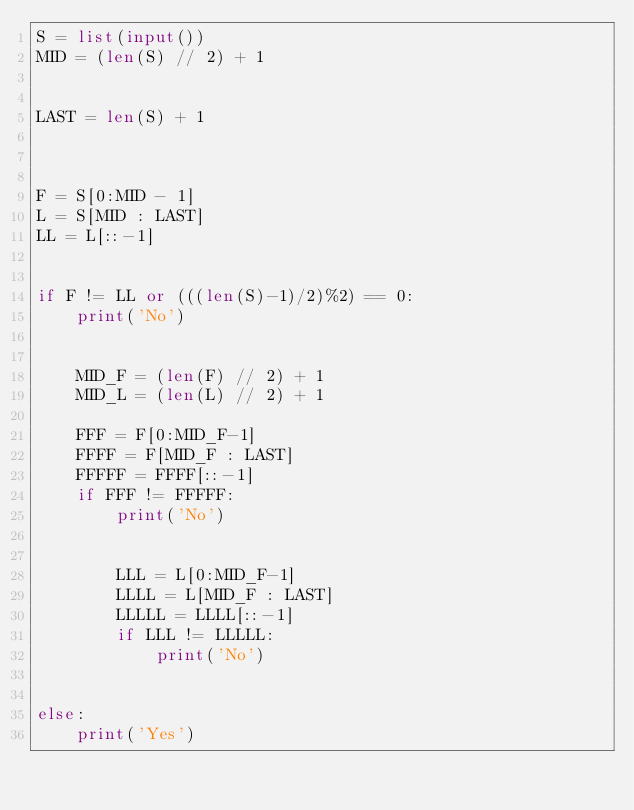Convert code to text. <code><loc_0><loc_0><loc_500><loc_500><_Python_>S = list(input())
MID = (len(S) // 2) + 1


LAST = len(S) + 1



F = S[0:MID - 1]
L = S[MID : LAST]
LL = L[::-1]


if F != LL or (((len(S)-1)/2)%2) == 0:
    print('No')

    
    MID_F = (len(F) // 2) + 1
    MID_L = (len(L) // 2) + 1

    FFF = F[0:MID_F-1]
    FFFF = F[MID_F : LAST]
    FFFFF = FFFF[::-1]
    if FFF != FFFFF:
        print('No')


        LLL = L[0:MID_F-1]
        LLLL = L[MID_F : LAST]
        LLLLL = LLLL[::-1]
        if LLL != LLLLL:
            print('No')

            
else:
    print('Yes')</code> 